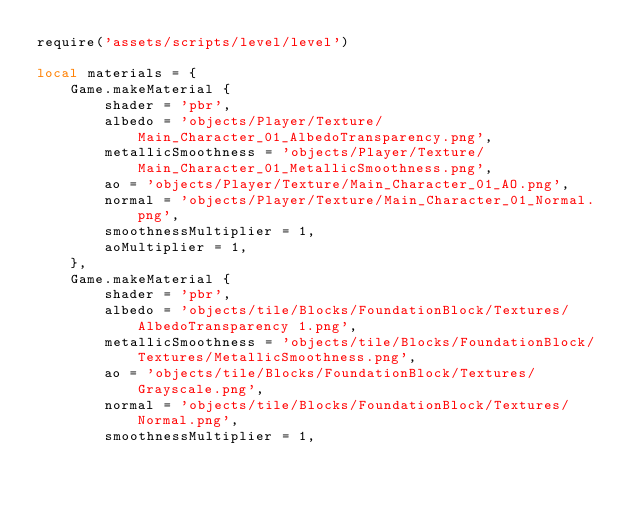Convert code to text. <code><loc_0><loc_0><loc_500><loc_500><_Lua_>require('assets/scripts/level/level')

local materials = {
    Game.makeMaterial {
        shader = 'pbr',
        albedo = 'objects/Player/Texture/Main_Character_01_AlbedoTransparency.png',
        metallicSmoothness = 'objects/Player/Texture/Main_Character_01_MetallicSmoothness.png',
        ao = 'objects/Player/Texture/Main_Character_01_AO.png',
        normal = 'objects/Player/Texture/Main_Character_01_Normal.png',
        smoothnessMultiplier = 1,
        aoMultiplier = 1,
    },
    Game.makeMaterial {
        shader = 'pbr',
        albedo = 'objects/tile/Blocks/FoundationBlock/Textures/AlbedoTransparency 1.png',
        metallicSmoothness = 'objects/tile/Blocks/FoundationBlock/Textures/MetallicSmoothness.png',
        ao = 'objects/tile/Blocks/FoundationBlock/Textures/Grayscale.png',
        normal = 'objects/tile/Blocks/FoundationBlock/Textures/Normal.png',
        smoothnessMultiplier = 1,</code> 